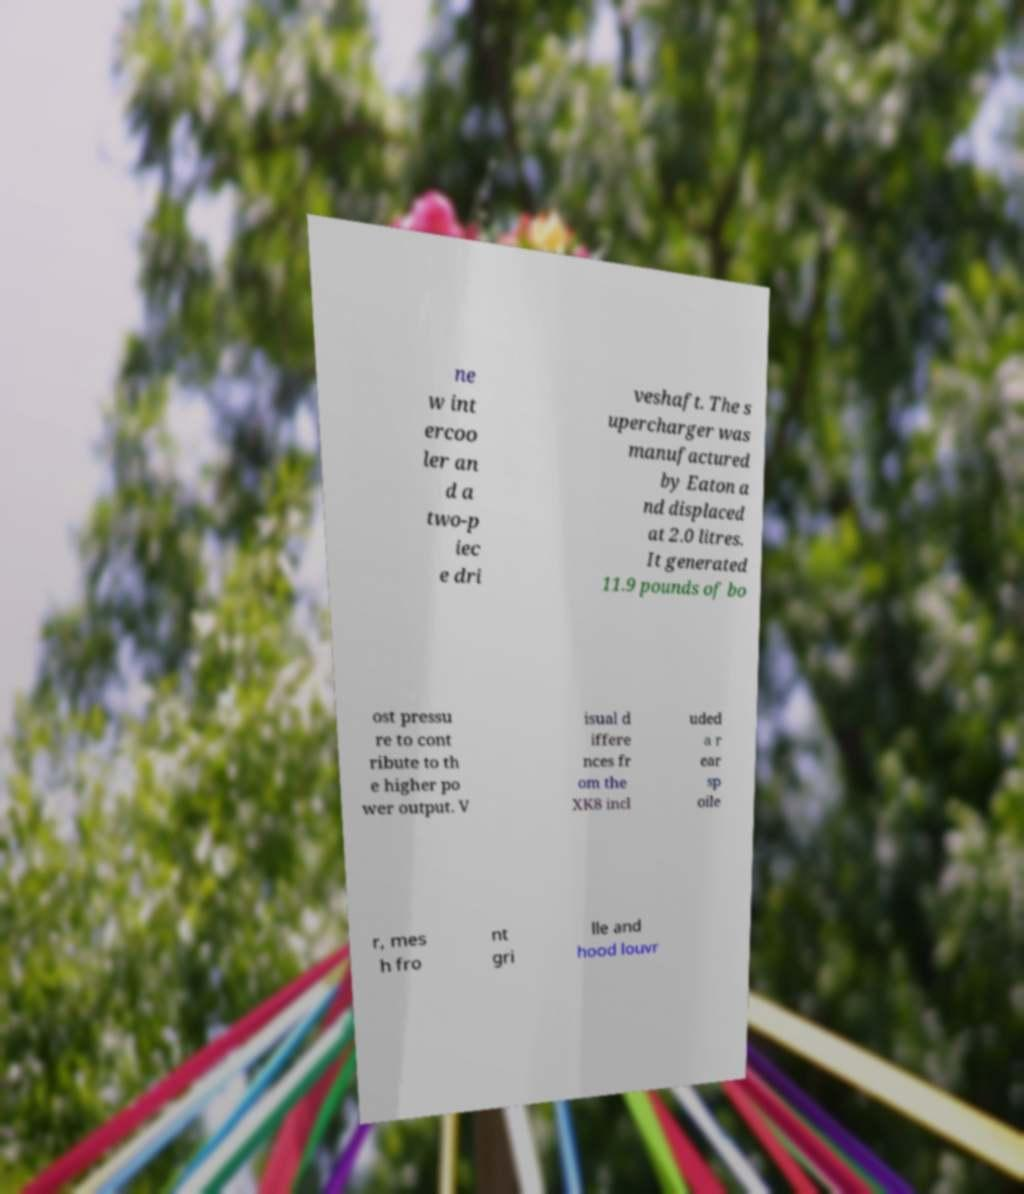Please identify and transcribe the text found in this image. ne w int ercoo ler an d a two-p iec e dri veshaft. The s upercharger was manufactured by Eaton a nd displaced at 2.0 litres. It generated 11.9 pounds of bo ost pressu re to cont ribute to th e higher po wer output. V isual d iffere nces fr om the XK8 incl uded a r ear sp oile r, mes h fro nt gri lle and hood louvr 